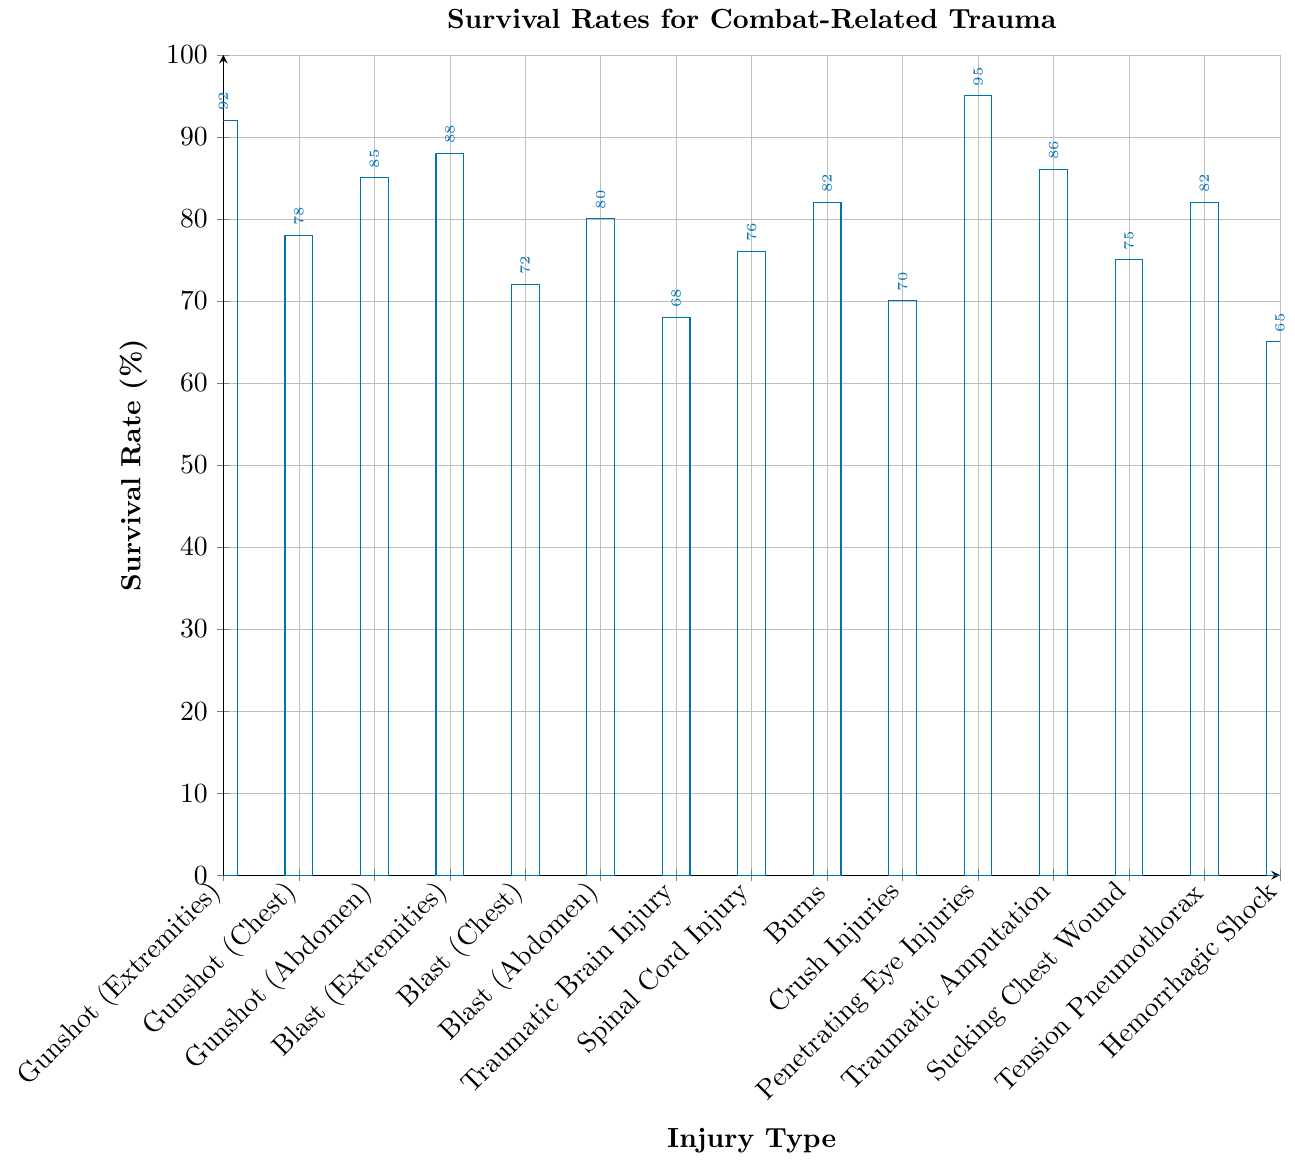Which injury type has the highest survival rate? By looking for the tallest bar, the highest survival rate corresponds to "Penetrating Eye Injuries".
Answer: Penetrating Eye Injuries Which injury type has the lowest survival rate? The shortest bar represents the lowest survival rate, which corresponds to "Hemorrhagic Shock".
Answer: Hemorrhagic Shock What is the survival rate difference between Gunshot to Chest and Gunshot to Extremities? The survival rate for Gunshot to Chest is 78% and for Gunshot to Extremities is 92%. The difference is 92% - 78% = 14%.
Answer: 14% Is the survival rate for Blast Injury to Abdomen higher or lower than for Traumatic Amputation? The Blast Injury to Abdomen has a rate of 80%, while Traumatic Amputation is 86%. It’s lower.
Answer: Lower How does the survival rate of Traumatic Brain Injury compare to that of Spinal Cord Injury? Traumatic Brain Injury has a survival rate of 68%, and Spinal Cord Injury has 76%. Traumatic Brain Injury has a lower survival rate.
Answer: Lower What is the average survival rate of all Gunshot Wound categories? Gunshot to Extremities (92%), to Chest (78%), and to Abdomen (85%). Average = (92+78+85)/3 = 85%.
Answer: 85% Which injury type has a survival rate closest to 70%? The bar at 70% corresponds to "Crush Injuries".
Answer: Crush Injuries How many injury types have a survival rate higher than 80%? Count the bars higher than 80%: Gunshot (Extremities), Gunshot (Abdomen), Blast (Extremities), Burns, Penetrating Eye Injuries, Traumatic Amputation, Tension Pneumothorax. There are 7 types.
Answer: 7 What is the combined survival rate for Tension Pneumothorax and Sucking Chest Wound? Tension Pneumothorax (82%) + Sucking Chest Wound (75%) = 157%.
Answer: 157% What is the survival rate range for injuries caused by blasts? Blast to Extremities (88%), Chest (72%), and Abdomen (80%). The range is 88% - 72% = 16%.
Answer: 16% 